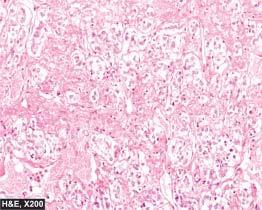does the alveolar lumina have typical zellballen or nested pattern?
Answer the question using a single word or phrase. No 